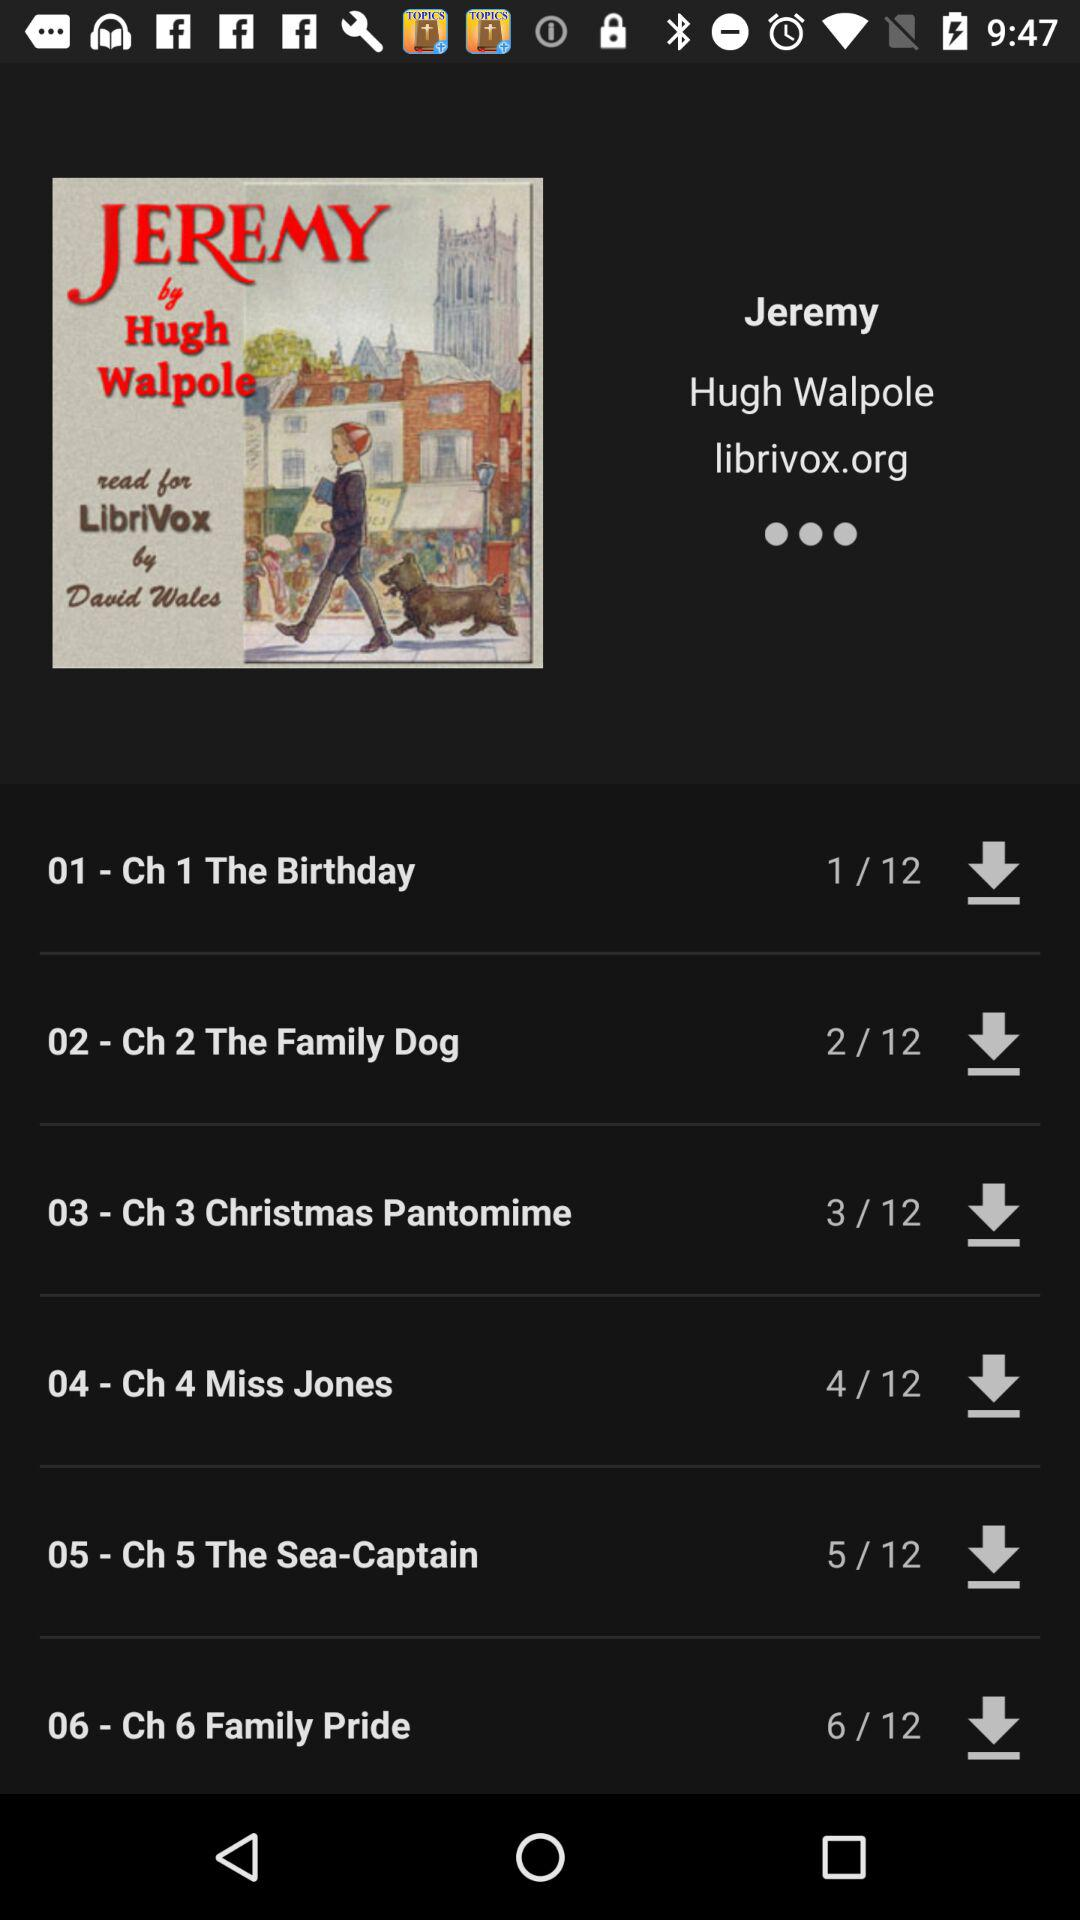How long is "Ch 1 The Birthday"?
When the provided information is insufficient, respond with <no answer>. <no answer> 